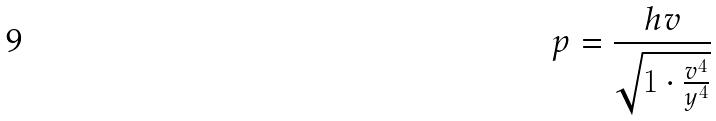<formula> <loc_0><loc_0><loc_500><loc_500>p = \frac { h v } { \sqrt { 1 \cdot \frac { v ^ { 4 } } { y ^ { 4 } } } }</formula> 